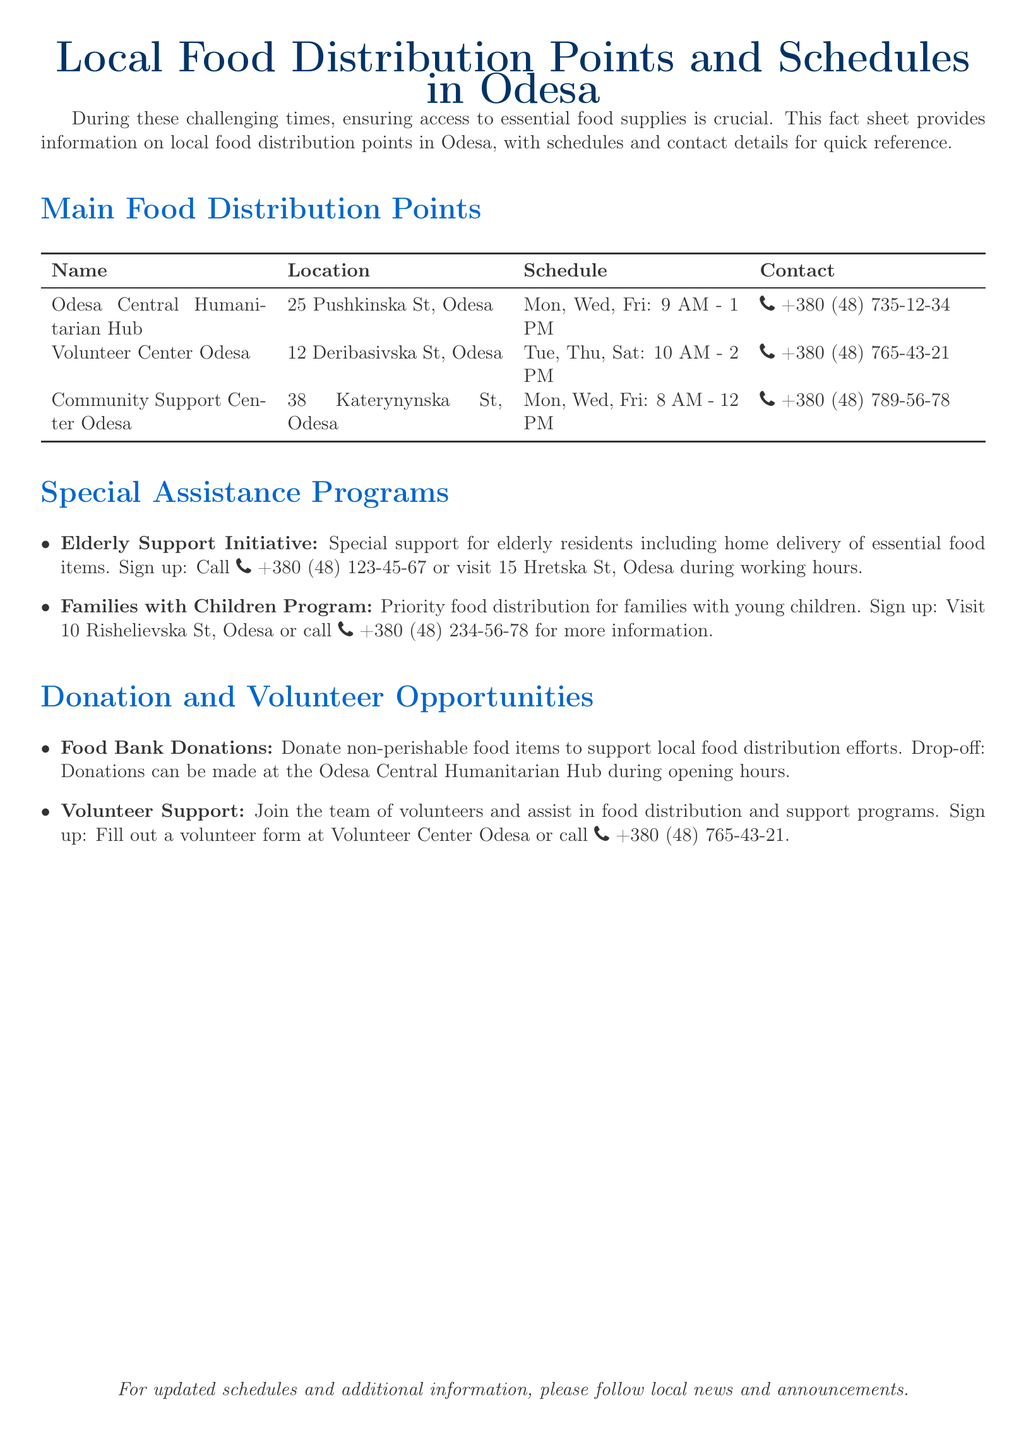What is the address of the Odesa Central Humanitarian Hub? The address is specified in the table under the Name "Odesa Central Humanitarian Hub."
Answer: 25 Pushkinska St, Odesa What day is food distributed at the Volunteer Center Odesa? The schedule is listed in the table for the Volunteer Center Odesa.
Answer: Tue, Thu, Sat What is the contact number for Community Support Center Odesa? The contact number is given in the table under the Contact column for Community Support Center Odesa.
Answer: +380 (48) 789-56-78 What special program supports elderly residents? The document mentions programs, and the one specifically for elderly residents is labeled as the Elderly Support Initiative.
Answer: Elderly Support Initiative How often does the Odesa Central Humanitarian Hub distribute food? The distribution schedule indicates how frequently food is provided at this hub.
Answer: Three times a week What is the focus of the Families with Children Program? The program aims to prioritize support for a specific demographic, as mentioned in the list of special assistance programs.
Answer: Families with young children Where can donations be made? The location for drop-off donations is specified in the section about donation opportunities.
Answer: Odesa Central Humanitarian Hub What do volunteers assist with? The document specifies the types of support volunteers are involved in, focusing on the food distribution efforts.
Answer: Food distribution and support programs 